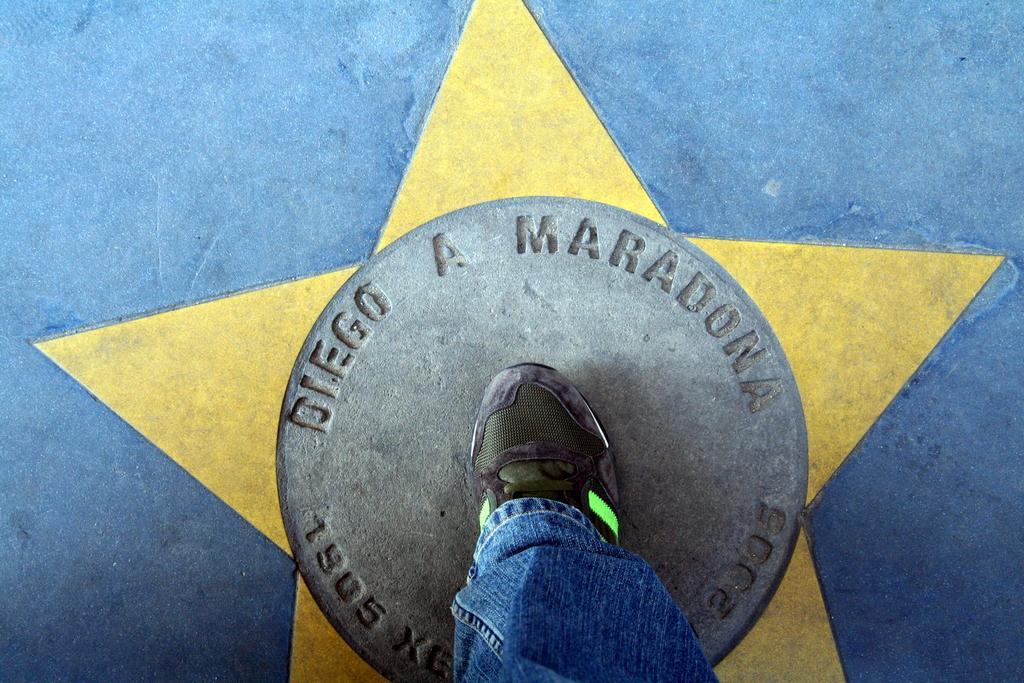Can you describe this image briefly? There is one human leg is present at the bottom of this image and there is a floor in the background. 